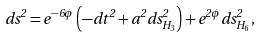Convert formula to latex. <formula><loc_0><loc_0><loc_500><loc_500>d s ^ { 2 } = e ^ { - 6 \phi } \left ( - d t ^ { 2 } + a ^ { 2 } d s _ { H _ { 3 } } ^ { 2 } \right ) + e ^ { 2 \phi } d s _ { H _ { 6 } } ^ { 2 } ,</formula> 